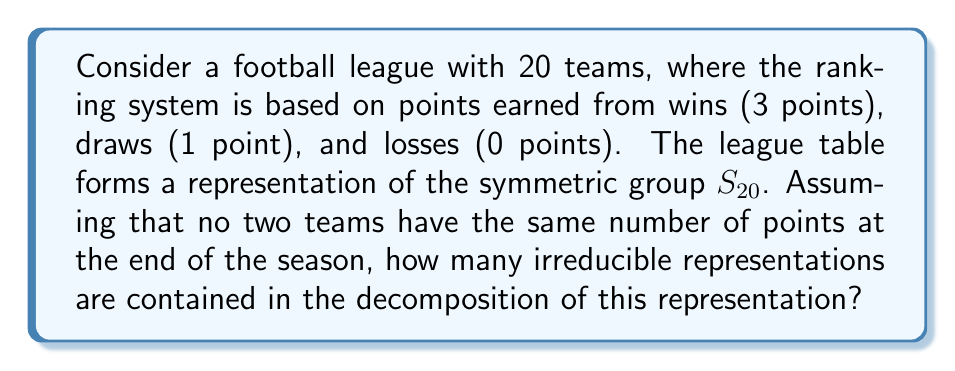Can you answer this question? Let's approach this step-by-step:

1) The ranking system forms a permutation representation of $S_{20}$, as the teams can be arranged in any order based on their points.

2) This permutation representation is isomorphic to the regular representation of $S_{20}$, as each possible ranking corresponds to a unique permutation.

3) The regular representation of a finite group $G$ decomposes into a direct sum of all irreducible representations, with each appearing with multiplicity equal to its dimension:

   $$R_G \cong \bigoplus_i n_i V_i$$

   where $n_i = \dim(V_i)$

4) For the symmetric group $S_n$, the number of irreducible representations is equal to the number of partitions of $n$.

5) The number of partitions of 20 can be calculated using the partition function $p(n)$. While there's no simple closed form for $p(n)$, it's a well-known value for small $n$.

6) For $n = 20$, $p(20) = 627$.

Therefore, the regular representation of $S_{20}$, and consequently our ranking system representation, decomposes into 627 irreducible representations, each appearing with multiplicity equal to its dimension.
Answer: 627 